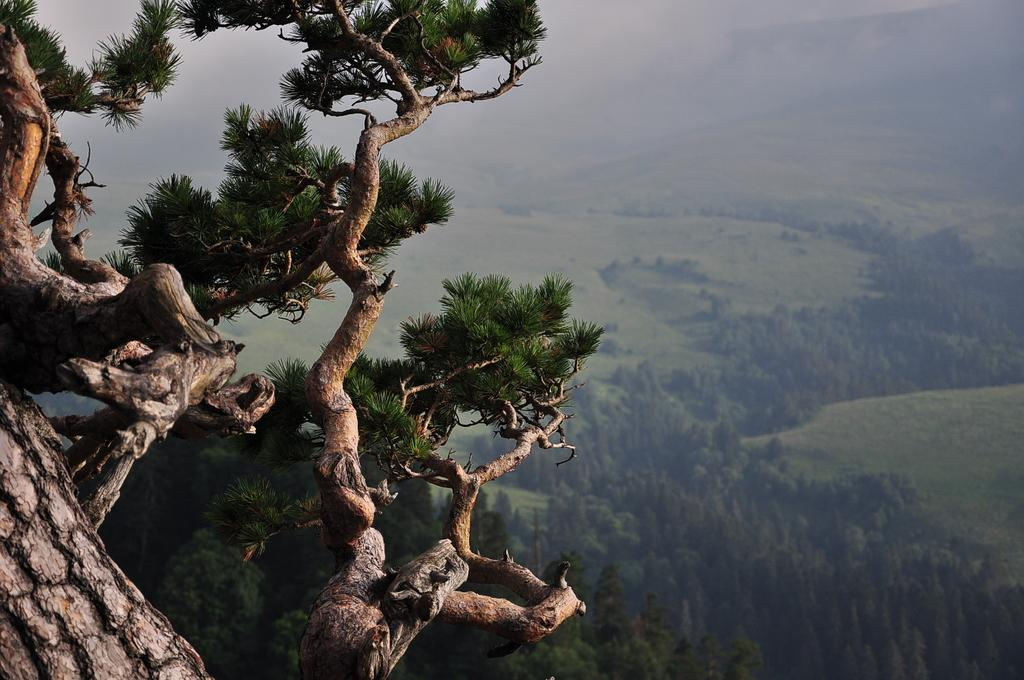What type of plant can be seen in the image? There is a tree in the image. What type of vegetation is visible in the background of the image? There is grass and trees in the background of the image. Where is the boot located in the image? There is no boot present in the image. What type of education can be seen in the image? There is no reference to education in the image. 